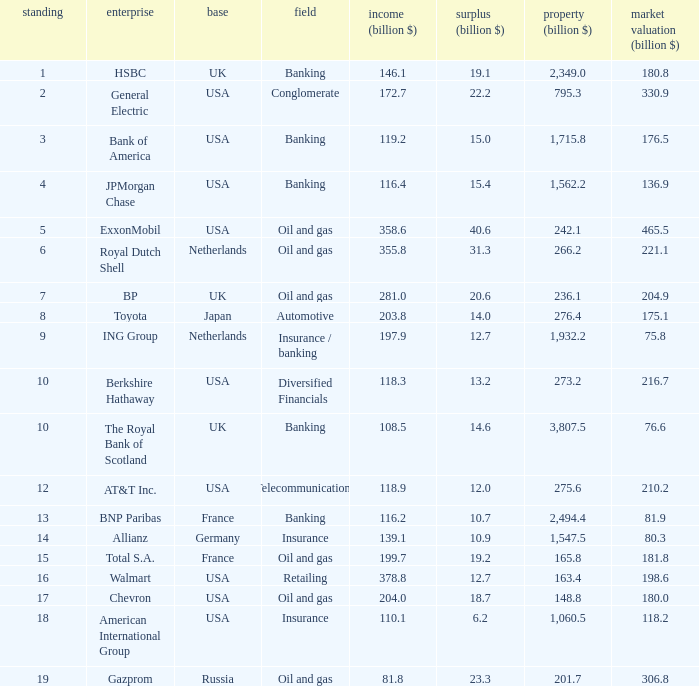What is the market value of a company in billions that has 172.7 billion in sales?  330.9. 